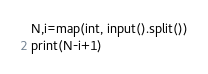<code> <loc_0><loc_0><loc_500><loc_500><_Python_>N,i=map(int, input().split())
print(N-i+1)</code> 